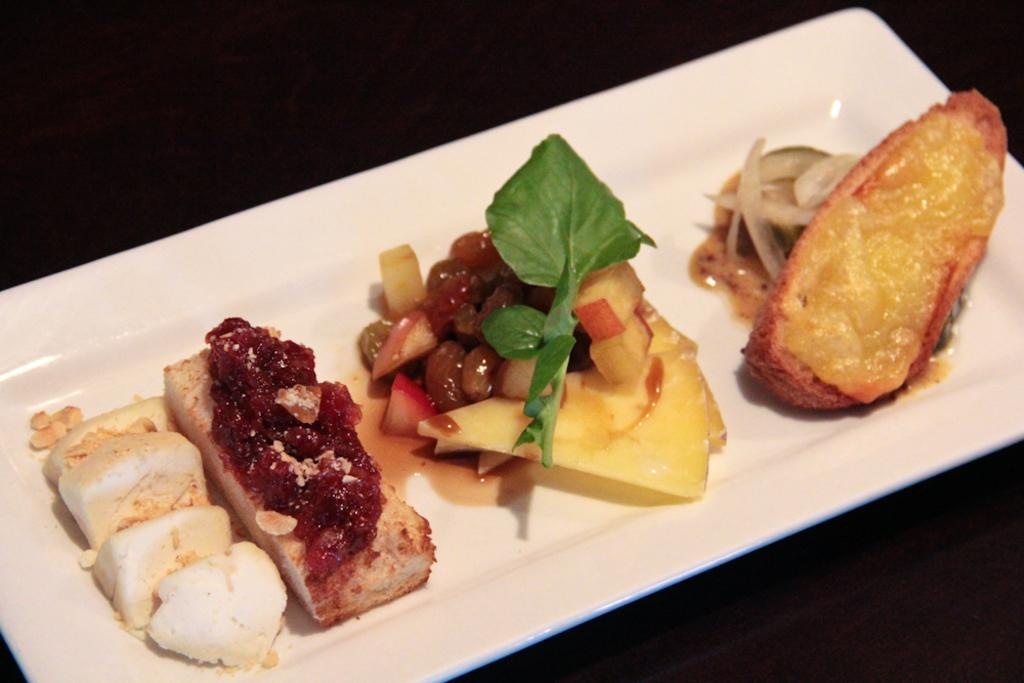What is on the tray that is visible in the image? There is a tray with food in the image. Can you describe the background of the image? The background of the image is dark. What reason is given for the food being served in the image? There is no reason provided for the food being served in the image. What day of the week is depicted in the image? The day of the week is not visible or mentioned in the image. 